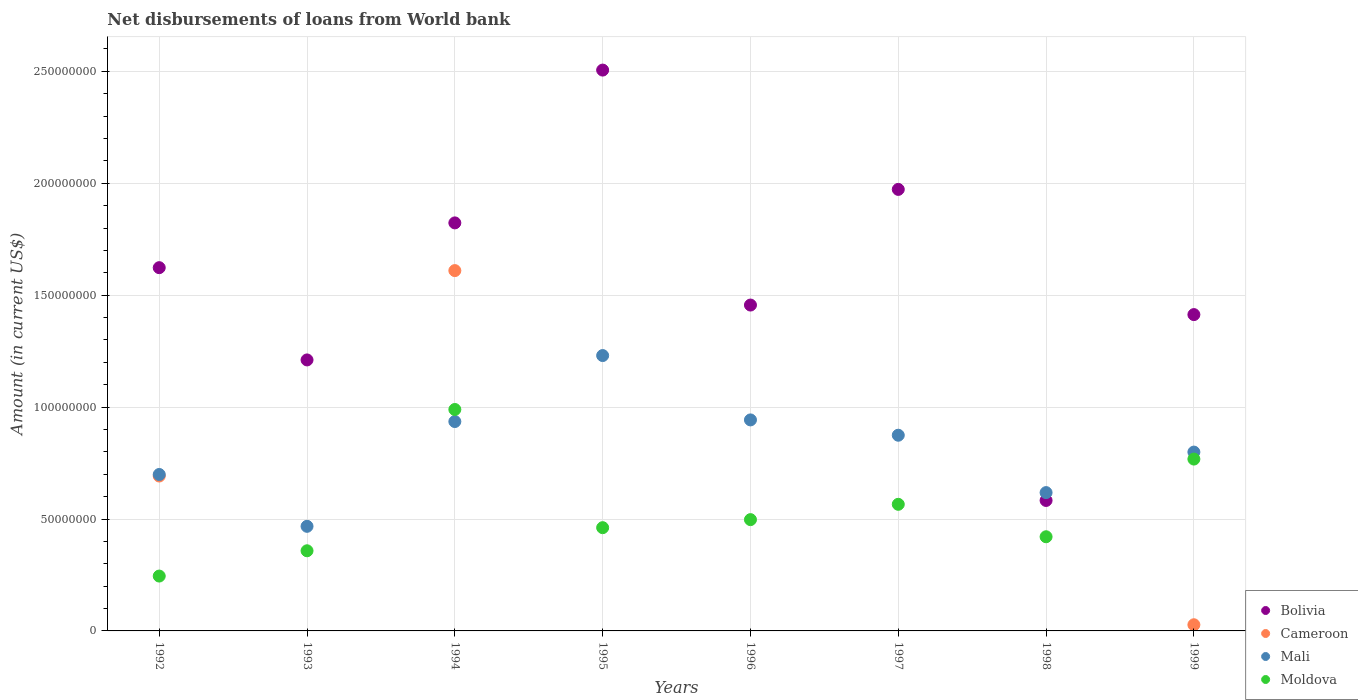Is the number of dotlines equal to the number of legend labels?
Your response must be concise. No. What is the amount of loan disbursed from World Bank in Moldova in 1997?
Offer a very short reply. 5.66e+07. Across all years, what is the maximum amount of loan disbursed from World Bank in Moldova?
Offer a terse response. 9.89e+07. Across all years, what is the minimum amount of loan disbursed from World Bank in Mali?
Ensure brevity in your answer.  4.67e+07. What is the total amount of loan disbursed from World Bank in Bolivia in the graph?
Offer a very short reply. 1.26e+09. What is the difference between the amount of loan disbursed from World Bank in Bolivia in 1992 and that in 1997?
Provide a succinct answer. -3.50e+07. What is the difference between the amount of loan disbursed from World Bank in Mali in 1992 and the amount of loan disbursed from World Bank in Bolivia in 1997?
Provide a succinct answer. -1.27e+08. What is the average amount of loan disbursed from World Bank in Moldova per year?
Give a very brief answer. 5.38e+07. In the year 1993, what is the difference between the amount of loan disbursed from World Bank in Bolivia and amount of loan disbursed from World Bank in Moldova?
Make the answer very short. 8.53e+07. In how many years, is the amount of loan disbursed from World Bank in Cameroon greater than 50000000 US$?
Offer a very short reply. 2. What is the ratio of the amount of loan disbursed from World Bank in Moldova in 1994 to that in 1998?
Give a very brief answer. 2.35. Is the amount of loan disbursed from World Bank in Bolivia in 1994 less than that in 1998?
Offer a very short reply. No. What is the difference between the highest and the second highest amount of loan disbursed from World Bank in Moldova?
Your response must be concise. 2.22e+07. What is the difference between the highest and the lowest amount of loan disbursed from World Bank in Bolivia?
Provide a succinct answer. 1.92e+08. In how many years, is the amount of loan disbursed from World Bank in Moldova greater than the average amount of loan disbursed from World Bank in Moldova taken over all years?
Provide a short and direct response. 3. Is the amount of loan disbursed from World Bank in Bolivia strictly less than the amount of loan disbursed from World Bank in Moldova over the years?
Your response must be concise. No. How many years are there in the graph?
Make the answer very short. 8. Are the values on the major ticks of Y-axis written in scientific E-notation?
Offer a very short reply. No. Where does the legend appear in the graph?
Offer a terse response. Bottom right. What is the title of the graph?
Your answer should be compact. Net disbursements of loans from World bank. Does "Slovenia" appear as one of the legend labels in the graph?
Give a very brief answer. No. What is the label or title of the Y-axis?
Offer a very short reply. Amount (in current US$). What is the Amount (in current US$) of Bolivia in 1992?
Your answer should be very brief. 1.62e+08. What is the Amount (in current US$) in Cameroon in 1992?
Give a very brief answer. 6.92e+07. What is the Amount (in current US$) in Mali in 1992?
Provide a short and direct response. 6.99e+07. What is the Amount (in current US$) of Moldova in 1992?
Offer a terse response. 2.45e+07. What is the Amount (in current US$) in Bolivia in 1993?
Provide a succinct answer. 1.21e+08. What is the Amount (in current US$) in Mali in 1993?
Your response must be concise. 4.67e+07. What is the Amount (in current US$) in Moldova in 1993?
Keep it short and to the point. 3.58e+07. What is the Amount (in current US$) in Bolivia in 1994?
Keep it short and to the point. 1.82e+08. What is the Amount (in current US$) in Cameroon in 1994?
Your response must be concise. 1.61e+08. What is the Amount (in current US$) in Mali in 1994?
Make the answer very short. 9.35e+07. What is the Amount (in current US$) of Moldova in 1994?
Ensure brevity in your answer.  9.89e+07. What is the Amount (in current US$) in Bolivia in 1995?
Your answer should be compact. 2.51e+08. What is the Amount (in current US$) of Mali in 1995?
Keep it short and to the point. 1.23e+08. What is the Amount (in current US$) of Moldova in 1995?
Make the answer very short. 4.61e+07. What is the Amount (in current US$) in Bolivia in 1996?
Ensure brevity in your answer.  1.46e+08. What is the Amount (in current US$) of Mali in 1996?
Keep it short and to the point. 9.43e+07. What is the Amount (in current US$) of Moldova in 1996?
Provide a short and direct response. 4.97e+07. What is the Amount (in current US$) of Bolivia in 1997?
Ensure brevity in your answer.  1.97e+08. What is the Amount (in current US$) of Cameroon in 1997?
Your answer should be compact. 0. What is the Amount (in current US$) of Mali in 1997?
Make the answer very short. 8.74e+07. What is the Amount (in current US$) in Moldova in 1997?
Ensure brevity in your answer.  5.66e+07. What is the Amount (in current US$) in Bolivia in 1998?
Your answer should be compact. 5.83e+07. What is the Amount (in current US$) in Mali in 1998?
Keep it short and to the point. 6.18e+07. What is the Amount (in current US$) of Moldova in 1998?
Offer a very short reply. 4.21e+07. What is the Amount (in current US$) in Bolivia in 1999?
Your response must be concise. 1.41e+08. What is the Amount (in current US$) in Cameroon in 1999?
Offer a terse response. 2.75e+06. What is the Amount (in current US$) of Mali in 1999?
Offer a very short reply. 7.99e+07. What is the Amount (in current US$) of Moldova in 1999?
Provide a succinct answer. 7.68e+07. Across all years, what is the maximum Amount (in current US$) of Bolivia?
Your response must be concise. 2.51e+08. Across all years, what is the maximum Amount (in current US$) of Cameroon?
Offer a very short reply. 1.61e+08. Across all years, what is the maximum Amount (in current US$) in Mali?
Your response must be concise. 1.23e+08. Across all years, what is the maximum Amount (in current US$) of Moldova?
Provide a short and direct response. 9.89e+07. Across all years, what is the minimum Amount (in current US$) of Bolivia?
Offer a terse response. 5.83e+07. Across all years, what is the minimum Amount (in current US$) in Cameroon?
Your answer should be very brief. 0. Across all years, what is the minimum Amount (in current US$) of Mali?
Your answer should be very brief. 4.67e+07. Across all years, what is the minimum Amount (in current US$) of Moldova?
Make the answer very short. 2.45e+07. What is the total Amount (in current US$) of Bolivia in the graph?
Your answer should be very brief. 1.26e+09. What is the total Amount (in current US$) of Cameroon in the graph?
Offer a very short reply. 2.33e+08. What is the total Amount (in current US$) of Mali in the graph?
Your answer should be very brief. 6.57e+08. What is the total Amount (in current US$) in Moldova in the graph?
Your answer should be very brief. 4.31e+08. What is the difference between the Amount (in current US$) in Bolivia in 1992 and that in 1993?
Your answer should be compact. 4.12e+07. What is the difference between the Amount (in current US$) in Mali in 1992 and that in 1993?
Ensure brevity in your answer.  2.32e+07. What is the difference between the Amount (in current US$) of Moldova in 1992 and that in 1993?
Make the answer very short. -1.13e+07. What is the difference between the Amount (in current US$) in Bolivia in 1992 and that in 1994?
Make the answer very short. -2.00e+07. What is the difference between the Amount (in current US$) of Cameroon in 1992 and that in 1994?
Your answer should be very brief. -9.18e+07. What is the difference between the Amount (in current US$) of Mali in 1992 and that in 1994?
Keep it short and to the point. -2.36e+07. What is the difference between the Amount (in current US$) of Moldova in 1992 and that in 1994?
Provide a succinct answer. -7.44e+07. What is the difference between the Amount (in current US$) in Bolivia in 1992 and that in 1995?
Your answer should be very brief. -8.83e+07. What is the difference between the Amount (in current US$) of Mali in 1992 and that in 1995?
Provide a succinct answer. -5.31e+07. What is the difference between the Amount (in current US$) in Moldova in 1992 and that in 1995?
Provide a short and direct response. -2.16e+07. What is the difference between the Amount (in current US$) of Bolivia in 1992 and that in 1996?
Your answer should be very brief. 1.67e+07. What is the difference between the Amount (in current US$) of Mali in 1992 and that in 1996?
Ensure brevity in your answer.  -2.44e+07. What is the difference between the Amount (in current US$) in Moldova in 1992 and that in 1996?
Offer a very short reply. -2.52e+07. What is the difference between the Amount (in current US$) of Bolivia in 1992 and that in 1997?
Provide a succinct answer. -3.50e+07. What is the difference between the Amount (in current US$) of Mali in 1992 and that in 1997?
Your response must be concise. -1.75e+07. What is the difference between the Amount (in current US$) of Moldova in 1992 and that in 1997?
Keep it short and to the point. -3.21e+07. What is the difference between the Amount (in current US$) of Bolivia in 1992 and that in 1998?
Your answer should be very brief. 1.04e+08. What is the difference between the Amount (in current US$) in Mali in 1992 and that in 1998?
Provide a succinct answer. 8.10e+06. What is the difference between the Amount (in current US$) of Moldova in 1992 and that in 1998?
Give a very brief answer. -1.76e+07. What is the difference between the Amount (in current US$) of Bolivia in 1992 and that in 1999?
Give a very brief answer. 2.10e+07. What is the difference between the Amount (in current US$) in Cameroon in 1992 and that in 1999?
Offer a terse response. 6.65e+07. What is the difference between the Amount (in current US$) of Mali in 1992 and that in 1999?
Keep it short and to the point. -1.00e+07. What is the difference between the Amount (in current US$) of Moldova in 1992 and that in 1999?
Give a very brief answer. -5.23e+07. What is the difference between the Amount (in current US$) in Bolivia in 1993 and that in 1994?
Provide a short and direct response. -6.12e+07. What is the difference between the Amount (in current US$) of Mali in 1993 and that in 1994?
Keep it short and to the point. -4.68e+07. What is the difference between the Amount (in current US$) of Moldova in 1993 and that in 1994?
Make the answer very short. -6.31e+07. What is the difference between the Amount (in current US$) in Bolivia in 1993 and that in 1995?
Your answer should be very brief. -1.29e+08. What is the difference between the Amount (in current US$) of Mali in 1993 and that in 1995?
Provide a short and direct response. -7.63e+07. What is the difference between the Amount (in current US$) of Moldova in 1993 and that in 1995?
Make the answer very short. -1.03e+07. What is the difference between the Amount (in current US$) in Bolivia in 1993 and that in 1996?
Your answer should be compact. -2.45e+07. What is the difference between the Amount (in current US$) in Mali in 1993 and that in 1996?
Your response must be concise. -4.75e+07. What is the difference between the Amount (in current US$) of Moldova in 1993 and that in 1996?
Provide a short and direct response. -1.39e+07. What is the difference between the Amount (in current US$) in Bolivia in 1993 and that in 1997?
Keep it short and to the point. -7.62e+07. What is the difference between the Amount (in current US$) in Mali in 1993 and that in 1997?
Offer a terse response. -4.07e+07. What is the difference between the Amount (in current US$) in Moldova in 1993 and that in 1997?
Offer a terse response. -2.08e+07. What is the difference between the Amount (in current US$) of Bolivia in 1993 and that in 1998?
Your response must be concise. 6.28e+07. What is the difference between the Amount (in current US$) in Mali in 1993 and that in 1998?
Your answer should be compact. -1.51e+07. What is the difference between the Amount (in current US$) in Moldova in 1993 and that in 1998?
Your answer should be compact. -6.27e+06. What is the difference between the Amount (in current US$) of Bolivia in 1993 and that in 1999?
Your answer should be compact. -2.03e+07. What is the difference between the Amount (in current US$) in Mali in 1993 and that in 1999?
Your answer should be compact. -3.32e+07. What is the difference between the Amount (in current US$) of Moldova in 1993 and that in 1999?
Ensure brevity in your answer.  -4.10e+07. What is the difference between the Amount (in current US$) of Bolivia in 1994 and that in 1995?
Ensure brevity in your answer.  -6.83e+07. What is the difference between the Amount (in current US$) of Mali in 1994 and that in 1995?
Provide a short and direct response. -2.95e+07. What is the difference between the Amount (in current US$) in Moldova in 1994 and that in 1995?
Provide a short and direct response. 5.28e+07. What is the difference between the Amount (in current US$) in Bolivia in 1994 and that in 1996?
Ensure brevity in your answer.  3.67e+07. What is the difference between the Amount (in current US$) in Mali in 1994 and that in 1996?
Offer a very short reply. -7.32e+05. What is the difference between the Amount (in current US$) in Moldova in 1994 and that in 1996?
Your answer should be compact. 4.92e+07. What is the difference between the Amount (in current US$) in Bolivia in 1994 and that in 1997?
Offer a very short reply. -1.50e+07. What is the difference between the Amount (in current US$) in Mali in 1994 and that in 1997?
Offer a very short reply. 6.11e+06. What is the difference between the Amount (in current US$) of Moldova in 1994 and that in 1997?
Give a very brief answer. 4.24e+07. What is the difference between the Amount (in current US$) in Bolivia in 1994 and that in 1998?
Ensure brevity in your answer.  1.24e+08. What is the difference between the Amount (in current US$) of Mali in 1994 and that in 1998?
Provide a succinct answer. 3.17e+07. What is the difference between the Amount (in current US$) of Moldova in 1994 and that in 1998?
Offer a terse response. 5.69e+07. What is the difference between the Amount (in current US$) in Bolivia in 1994 and that in 1999?
Keep it short and to the point. 4.10e+07. What is the difference between the Amount (in current US$) in Cameroon in 1994 and that in 1999?
Keep it short and to the point. 1.58e+08. What is the difference between the Amount (in current US$) of Mali in 1994 and that in 1999?
Keep it short and to the point. 1.36e+07. What is the difference between the Amount (in current US$) in Moldova in 1994 and that in 1999?
Provide a succinct answer. 2.22e+07. What is the difference between the Amount (in current US$) of Bolivia in 1995 and that in 1996?
Your answer should be very brief. 1.05e+08. What is the difference between the Amount (in current US$) of Mali in 1995 and that in 1996?
Offer a very short reply. 2.87e+07. What is the difference between the Amount (in current US$) of Moldova in 1995 and that in 1996?
Your answer should be very brief. -3.59e+06. What is the difference between the Amount (in current US$) of Bolivia in 1995 and that in 1997?
Offer a terse response. 5.33e+07. What is the difference between the Amount (in current US$) in Mali in 1995 and that in 1997?
Give a very brief answer. 3.56e+07. What is the difference between the Amount (in current US$) in Moldova in 1995 and that in 1997?
Provide a succinct answer. -1.04e+07. What is the difference between the Amount (in current US$) of Bolivia in 1995 and that in 1998?
Ensure brevity in your answer.  1.92e+08. What is the difference between the Amount (in current US$) in Mali in 1995 and that in 1998?
Keep it short and to the point. 6.12e+07. What is the difference between the Amount (in current US$) in Moldova in 1995 and that in 1998?
Offer a very short reply. 4.06e+06. What is the difference between the Amount (in current US$) in Bolivia in 1995 and that in 1999?
Provide a short and direct response. 1.09e+08. What is the difference between the Amount (in current US$) of Mali in 1995 and that in 1999?
Offer a terse response. 4.31e+07. What is the difference between the Amount (in current US$) of Moldova in 1995 and that in 1999?
Offer a very short reply. -3.07e+07. What is the difference between the Amount (in current US$) of Bolivia in 1996 and that in 1997?
Offer a very short reply. -5.17e+07. What is the difference between the Amount (in current US$) of Mali in 1996 and that in 1997?
Make the answer very short. 6.85e+06. What is the difference between the Amount (in current US$) in Moldova in 1996 and that in 1997?
Your answer should be compact. -6.85e+06. What is the difference between the Amount (in current US$) in Bolivia in 1996 and that in 1998?
Give a very brief answer. 8.73e+07. What is the difference between the Amount (in current US$) in Mali in 1996 and that in 1998?
Keep it short and to the point. 3.25e+07. What is the difference between the Amount (in current US$) in Moldova in 1996 and that in 1998?
Offer a very short reply. 7.65e+06. What is the difference between the Amount (in current US$) in Bolivia in 1996 and that in 1999?
Make the answer very short. 4.26e+06. What is the difference between the Amount (in current US$) of Mali in 1996 and that in 1999?
Provide a succinct answer. 1.44e+07. What is the difference between the Amount (in current US$) of Moldova in 1996 and that in 1999?
Make the answer very short. -2.71e+07. What is the difference between the Amount (in current US$) of Bolivia in 1997 and that in 1998?
Offer a terse response. 1.39e+08. What is the difference between the Amount (in current US$) of Mali in 1997 and that in 1998?
Provide a succinct answer. 2.56e+07. What is the difference between the Amount (in current US$) in Moldova in 1997 and that in 1998?
Provide a short and direct response. 1.45e+07. What is the difference between the Amount (in current US$) in Bolivia in 1997 and that in 1999?
Your answer should be very brief. 5.59e+07. What is the difference between the Amount (in current US$) in Mali in 1997 and that in 1999?
Your response must be concise. 7.53e+06. What is the difference between the Amount (in current US$) in Moldova in 1997 and that in 1999?
Ensure brevity in your answer.  -2.02e+07. What is the difference between the Amount (in current US$) in Bolivia in 1998 and that in 1999?
Make the answer very short. -8.30e+07. What is the difference between the Amount (in current US$) of Mali in 1998 and that in 1999?
Your answer should be very brief. -1.81e+07. What is the difference between the Amount (in current US$) of Moldova in 1998 and that in 1999?
Offer a very short reply. -3.47e+07. What is the difference between the Amount (in current US$) in Bolivia in 1992 and the Amount (in current US$) in Mali in 1993?
Your response must be concise. 1.16e+08. What is the difference between the Amount (in current US$) of Bolivia in 1992 and the Amount (in current US$) of Moldova in 1993?
Keep it short and to the point. 1.26e+08. What is the difference between the Amount (in current US$) in Cameroon in 1992 and the Amount (in current US$) in Mali in 1993?
Ensure brevity in your answer.  2.25e+07. What is the difference between the Amount (in current US$) of Cameroon in 1992 and the Amount (in current US$) of Moldova in 1993?
Ensure brevity in your answer.  3.34e+07. What is the difference between the Amount (in current US$) of Mali in 1992 and the Amount (in current US$) of Moldova in 1993?
Your response must be concise. 3.41e+07. What is the difference between the Amount (in current US$) of Bolivia in 1992 and the Amount (in current US$) of Cameroon in 1994?
Provide a succinct answer. 1.31e+06. What is the difference between the Amount (in current US$) in Bolivia in 1992 and the Amount (in current US$) in Mali in 1994?
Give a very brief answer. 6.87e+07. What is the difference between the Amount (in current US$) of Bolivia in 1992 and the Amount (in current US$) of Moldova in 1994?
Provide a succinct answer. 6.34e+07. What is the difference between the Amount (in current US$) of Cameroon in 1992 and the Amount (in current US$) of Mali in 1994?
Make the answer very short. -2.43e+07. What is the difference between the Amount (in current US$) of Cameroon in 1992 and the Amount (in current US$) of Moldova in 1994?
Ensure brevity in your answer.  -2.97e+07. What is the difference between the Amount (in current US$) in Mali in 1992 and the Amount (in current US$) in Moldova in 1994?
Provide a succinct answer. -2.90e+07. What is the difference between the Amount (in current US$) in Bolivia in 1992 and the Amount (in current US$) in Mali in 1995?
Provide a short and direct response. 3.93e+07. What is the difference between the Amount (in current US$) of Bolivia in 1992 and the Amount (in current US$) of Moldova in 1995?
Make the answer very short. 1.16e+08. What is the difference between the Amount (in current US$) of Cameroon in 1992 and the Amount (in current US$) of Mali in 1995?
Make the answer very short. -5.38e+07. What is the difference between the Amount (in current US$) of Cameroon in 1992 and the Amount (in current US$) of Moldova in 1995?
Give a very brief answer. 2.31e+07. What is the difference between the Amount (in current US$) in Mali in 1992 and the Amount (in current US$) in Moldova in 1995?
Your answer should be very brief. 2.38e+07. What is the difference between the Amount (in current US$) of Bolivia in 1992 and the Amount (in current US$) of Mali in 1996?
Your response must be concise. 6.80e+07. What is the difference between the Amount (in current US$) of Bolivia in 1992 and the Amount (in current US$) of Moldova in 1996?
Your answer should be compact. 1.13e+08. What is the difference between the Amount (in current US$) in Cameroon in 1992 and the Amount (in current US$) in Mali in 1996?
Give a very brief answer. -2.51e+07. What is the difference between the Amount (in current US$) of Cameroon in 1992 and the Amount (in current US$) of Moldova in 1996?
Your answer should be compact. 1.95e+07. What is the difference between the Amount (in current US$) in Mali in 1992 and the Amount (in current US$) in Moldova in 1996?
Keep it short and to the point. 2.02e+07. What is the difference between the Amount (in current US$) in Bolivia in 1992 and the Amount (in current US$) in Mali in 1997?
Your response must be concise. 7.49e+07. What is the difference between the Amount (in current US$) of Bolivia in 1992 and the Amount (in current US$) of Moldova in 1997?
Provide a succinct answer. 1.06e+08. What is the difference between the Amount (in current US$) of Cameroon in 1992 and the Amount (in current US$) of Mali in 1997?
Your answer should be compact. -1.82e+07. What is the difference between the Amount (in current US$) of Cameroon in 1992 and the Amount (in current US$) of Moldova in 1997?
Provide a short and direct response. 1.26e+07. What is the difference between the Amount (in current US$) in Mali in 1992 and the Amount (in current US$) in Moldova in 1997?
Your answer should be very brief. 1.33e+07. What is the difference between the Amount (in current US$) in Bolivia in 1992 and the Amount (in current US$) in Mali in 1998?
Provide a short and direct response. 1.00e+08. What is the difference between the Amount (in current US$) of Bolivia in 1992 and the Amount (in current US$) of Moldova in 1998?
Offer a terse response. 1.20e+08. What is the difference between the Amount (in current US$) in Cameroon in 1992 and the Amount (in current US$) in Mali in 1998?
Your response must be concise. 7.41e+06. What is the difference between the Amount (in current US$) of Cameroon in 1992 and the Amount (in current US$) of Moldova in 1998?
Your answer should be very brief. 2.71e+07. What is the difference between the Amount (in current US$) of Mali in 1992 and the Amount (in current US$) of Moldova in 1998?
Give a very brief answer. 2.78e+07. What is the difference between the Amount (in current US$) in Bolivia in 1992 and the Amount (in current US$) in Cameroon in 1999?
Provide a succinct answer. 1.60e+08. What is the difference between the Amount (in current US$) in Bolivia in 1992 and the Amount (in current US$) in Mali in 1999?
Offer a very short reply. 8.24e+07. What is the difference between the Amount (in current US$) in Bolivia in 1992 and the Amount (in current US$) in Moldova in 1999?
Provide a short and direct response. 8.55e+07. What is the difference between the Amount (in current US$) of Cameroon in 1992 and the Amount (in current US$) of Mali in 1999?
Ensure brevity in your answer.  -1.07e+07. What is the difference between the Amount (in current US$) of Cameroon in 1992 and the Amount (in current US$) of Moldova in 1999?
Your answer should be very brief. -7.58e+06. What is the difference between the Amount (in current US$) in Mali in 1992 and the Amount (in current US$) in Moldova in 1999?
Keep it short and to the point. -6.88e+06. What is the difference between the Amount (in current US$) in Bolivia in 1993 and the Amount (in current US$) in Cameroon in 1994?
Keep it short and to the point. -3.99e+07. What is the difference between the Amount (in current US$) in Bolivia in 1993 and the Amount (in current US$) in Mali in 1994?
Keep it short and to the point. 2.75e+07. What is the difference between the Amount (in current US$) of Bolivia in 1993 and the Amount (in current US$) of Moldova in 1994?
Ensure brevity in your answer.  2.21e+07. What is the difference between the Amount (in current US$) of Mali in 1993 and the Amount (in current US$) of Moldova in 1994?
Give a very brief answer. -5.22e+07. What is the difference between the Amount (in current US$) in Bolivia in 1993 and the Amount (in current US$) in Mali in 1995?
Your answer should be very brief. -1.95e+06. What is the difference between the Amount (in current US$) of Bolivia in 1993 and the Amount (in current US$) of Moldova in 1995?
Provide a short and direct response. 7.49e+07. What is the difference between the Amount (in current US$) in Mali in 1993 and the Amount (in current US$) in Moldova in 1995?
Provide a succinct answer. 6.07e+05. What is the difference between the Amount (in current US$) of Bolivia in 1993 and the Amount (in current US$) of Mali in 1996?
Your response must be concise. 2.68e+07. What is the difference between the Amount (in current US$) of Bolivia in 1993 and the Amount (in current US$) of Moldova in 1996?
Offer a terse response. 7.14e+07. What is the difference between the Amount (in current US$) in Mali in 1993 and the Amount (in current US$) in Moldova in 1996?
Your answer should be compact. -2.98e+06. What is the difference between the Amount (in current US$) in Bolivia in 1993 and the Amount (in current US$) in Mali in 1997?
Offer a terse response. 3.36e+07. What is the difference between the Amount (in current US$) of Bolivia in 1993 and the Amount (in current US$) of Moldova in 1997?
Offer a terse response. 6.45e+07. What is the difference between the Amount (in current US$) of Mali in 1993 and the Amount (in current US$) of Moldova in 1997?
Ensure brevity in your answer.  -9.83e+06. What is the difference between the Amount (in current US$) in Bolivia in 1993 and the Amount (in current US$) in Mali in 1998?
Provide a succinct answer. 5.93e+07. What is the difference between the Amount (in current US$) in Bolivia in 1993 and the Amount (in current US$) in Moldova in 1998?
Provide a short and direct response. 7.90e+07. What is the difference between the Amount (in current US$) of Mali in 1993 and the Amount (in current US$) of Moldova in 1998?
Offer a terse response. 4.66e+06. What is the difference between the Amount (in current US$) in Bolivia in 1993 and the Amount (in current US$) in Cameroon in 1999?
Keep it short and to the point. 1.18e+08. What is the difference between the Amount (in current US$) of Bolivia in 1993 and the Amount (in current US$) of Mali in 1999?
Your answer should be compact. 4.12e+07. What is the difference between the Amount (in current US$) of Bolivia in 1993 and the Amount (in current US$) of Moldova in 1999?
Your answer should be compact. 4.43e+07. What is the difference between the Amount (in current US$) in Mali in 1993 and the Amount (in current US$) in Moldova in 1999?
Your answer should be very brief. -3.00e+07. What is the difference between the Amount (in current US$) of Bolivia in 1994 and the Amount (in current US$) of Mali in 1995?
Provide a succinct answer. 5.93e+07. What is the difference between the Amount (in current US$) of Bolivia in 1994 and the Amount (in current US$) of Moldova in 1995?
Your response must be concise. 1.36e+08. What is the difference between the Amount (in current US$) of Cameroon in 1994 and the Amount (in current US$) of Mali in 1995?
Your response must be concise. 3.80e+07. What is the difference between the Amount (in current US$) in Cameroon in 1994 and the Amount (in current US$) in Moldova in 1995?
Ensure brevity in your answer.  1.15e+08. What is the difference between the Amount (in current US$) in Mali in 1994 and the Amount (in current US$) in Moldova in 1995?
Give a very brief answer. 4.74e+07. What is the difference between the Amount (in current US$) in Bolivia in 1994 and the Amount (in current US$) in Mali in 1996?
Give a very brief answer. 8.80e+07. What is the difference between the Amount (in current US$) of Bolivia in 1994 and the Amount (in current US$) of Moldova in 1996?
Offer a terse response. 1.33e+08. What is the difference between the Amount (in current US$) of Cameroon in 1994 and the Amount (in current US$) of Mali in 1996?
Provide a short and direct response. 6.67e+07. What is the difference between the Amount (in current US$) of Cameroon in 1994 and the Amount (in current US$) of Moldova in 1996?
Offer a terse response. 1.11e+08. What is the difference between the Amount (in current US$) of Mali in 1994 and the Amount (in current US$) of Moldova in 1996?
Your answer should be very brief. 4.38e+07. What is the difference between the Amount (in current US$) in Bolivia in 1994 and the Amount (in current US$) in Mali in 1997?
Provide a succinct answer. 9.49e+07. What is the difference between the Amount (in current US$) of Bolivia in 1994 and the Amount (in current US$) of Moldova in 1997?
Ensure brevity in your answer.  1.26e+08. What is the difference between the Amount (in current US$) in Cameroon in 1994 and the Amount (in current US$) in Mali in 1997?
Provide a succinct answer. 7.36e+07. What is the difference between the Amount (in current US$) of Cameroon in 1994 and the Amount (in current US$) of Moldova in 1997?
Your response must be concise. 1.04e+08. What is the difference between the Amount (in current US$) in Mali in 1994 and the Amount (in current US$) in Moldova in 1997?
Your answer should be compact. 3.70e+07. What is the difference between the Amount (in current US$) in Bolivia in 1994 and the Amount (in current US$) in Mali in 1998?
Give a very brief answer. 1.21e+08. What is the difference between the Amount (in current US$) of Bolivia in 1994 and the Amount (in current US$) of Moldova in 1998?
Make the answer very short. 1.40e+08. What is the difference between the Amount (in current US$) in Cameroon in 1994 and the Amount (in current US$) in Mali in 1998?
Provide a short and direct response. 9.92e+07. What is the difference between the Amount (in current US$) of Cameroon in 1994 and the Amount (in current US$) of Moldova in 1998?
Give a very brief answer. 1.19e+08. What is the difference between the Amount (in current US$) of Mali in 1994 and the Amount (in current US$) of Moldova in 1998?
Your answer should be compact. 5.15e+07. What is the difference between the Amount (in current US$) in Bolivia in 1994 and the Amount (in current US$) in Cameroon in 1999?
Provide a short and direct response. 1.80e+08. What is the difference between the Amount (in current US$) in Bolivia in 1994 and the Amount (in current US$) in Mali in 1999?
Your answer should be very brief. 1.02e+08. What is the difference between the Amount (in current US$) of Bolivia in 1994 and the Amount (in current US$) of Moldova in 1999?
Offer a very short reply. 1.06e+08. What is the difference between the Amount (in current US$) of Cameroon in 1994 and the Amount (in current US$) of Mali in 1999?
Ensure brevity in your answer.  8.11e+07. What is the difference between the Amount (in current US$) of Cameroon in 1994 and the Amount (in current US$) of Moldova in 1999?
Ensure brevity in your answer.  8.42e+07. What is the difference between the Amount (in current US$) of Mali in 1994 and the Amount (in current US$) of Moldova in 1999?
Your response must be concise. 1.68e+07. What is the difference between the Amount (in current US$) of Bolivia in 1995 and the Amount (in current US$) of Mali in 1996?
Ensure brevity in your answer.  1.56e+08. What is the difference between the Amount (in current US$) in Bolivia in 1995 and the Amount (in current US$) in Moldova in 1996?
Give a very brief answer. 2.01e+08. What is the difference between the Amount (in current US$) in Mali in 1995 and the Amount (in current US$) in Moldova in 1996?
Your answer should be very brief. 7.33e+07. What is the difference between the Amount (in current US$) of Bolivia in 1995 and the Amount (in current US$) of Mali in 1997?
Offer a very short reply. 1.63e+08. What is the difference between the Amount (in current US$) of Bolivia in 1995 and the Amount (in current US$) of Moldova in 1997?
Keep it short and to the point. 1.94e+08. What is the difference between the Amount (in current US$) in Mali in 1995 and the Amount (in current US$) in Moldova in 1997?
Offer a terse response. 6.65e+07. What is the difference between the Amount (in current US$) of Bolivia in 1995 and the Amount (in current US$) of Mali in 1998?
Keep it short and to the point. 1.89e+08. What is the difference between the Amount (in current US$) in Bolivia in 1995 and the Amount (in current US$) in Moldova in 1998?
Your answer should be compact. 2.08e+08. What is the difference between the Amount (in current US$) of Mali in 1995 and the Amount (in current US$) of Moldova in 1998?
Offer a very short reply. 8.10e+07. What is the difference between the Amount (in current US$) in Bolivia in 1995 and the Amount (in current US$) in Cameroon in 1999?
Give a very brief answer. 2.48e+08. What is the difference between the Amount (in current US$) in Bolivia in 1995 and the Amount (in current US$) in Mali in 1999?
Provide a short and direct response. 1.71e+08. What is the difference between the Amount (in current US$) of Bolivia in 1995 and the Amount (in current US$) of Moldova in 1999?
Give a very brief answer. 1.74e+08. What is the difference between the Amount (in current US$) in Mali in 1995 and the Amount (in current US$) in Moldova in 1999?
Keep it short and to the point. 4.62e+07. What is the difference between the Amount (in current US$) of Bolivia in 1996 and the Amount (in current US$) of Mali in 1997?
Your answer should be very brief. 5.82e+07. What is the difference between the Amount (in current US$) of Bolivia in 1996 and the Amount (in current US$) of Moldova in 1997?
Offer a terse response. 8.90e+07. What is the difference between the Amount (in current US$) in Mali in 1996 and the Amount (in current US$) in Moldova in 1997?
Keep it short and to the point. 3.77e+07. What is the difference between the Amount (in current US$) in Bolivia in 1996 and the Amount (in current US$) in Mali in 1998?
Give a very brief answer. 8.38e+07. What is the difference between the Amount (in current US$) of Bolivia in 1996 and the Amount (in current US$) of Moldova in 1998?
Your answer should be compact. 1.04e+08. What is the difference between the Amount (in current US$) in Mali in 1996 and the Amount (in current US$) in Moldova in 1998?
Your answer should be very brief. 5.22e+07. What is the difference between the Amount (in current US$) of Bolivia in 1996 and the Amount (in current US$) of Cameroon in 1999?
Your response must be concise. 1.43e+08. What is the difference between the Amount (in current US$) in Bolivia in 1996 and the Amount (in current US$) in Mali in 1999?
Your response must be concise. 6.57e+07. What is the difference between the Amount (in current US$) in Bolivia in 1996 and the Amount (in current US$) in Moldova in 1999?
Your answer should be very brief. 6.88e+07. What is the difference between the Amount (in current US$) in Mali in 1996 and the Amount (in current US$) in Moldova in 1999?
Your answer should be compact. 1.75e+07. What is the difference between the Amount (in current US$) in Bolivia in 1997 and the Amount (in current US$) in Mali in 1998?
Make the answer very short. 1.35e+08. What is the difference between the Amount (in current US$) of Bolivia in 1997 and the Amount (in current US$) of Moldova in 1998?
Your response must be concise. 1.55e+08. What is the difference between the Amount (in current US$) in Mali in 1997 and the Amount (in current US$) in Moldova in 1998?
Offer a terse response. 4.54e+07. What is the difference between the Amount (in current US$) in Bolivia in 1997 and the Amount (in current US$) in Cameroon in 1999?
Keep it short and to the point. 1.95e+08. What is the difference between the Amount (in current US$) in Bolivia in 1997 and the Amount (in current US$) in Mali in 1999?
Your answer should be very brief. 1.17e+08. What is the difference between the Amount (in current US$) of Bolivia in 1997 and the Amount (in current US$) of Moldova in 1999?
Keep it short and to the point. 1.20e+08. What is the difference between the Amount (in current US$) of Mali in 1997 and the Amount (in current US$) of Moldova in 1999?
Give a very brief answer. 1.07e+07. What is the difference between the Amount (in current US$) of Bolivia in 1998 and the Amount (in current US$) of Cameroon in 1999?
Keep it short and to the point. 5.55e+07. What is the difference between the Amount (in current US$) in Bolivia in 1998 and the Amount (in current US$) in Mali in 1999?
Offer a very short reply. -2.16e+07. What is the difference between the Amount (in current US$) of Bolivia in 1998 and the Amount (in current US$) of Moldova in 1999?
Offer a terse response. -1.85e+07. What is the difference between the Amount (in current US$) in Mali in 1998 and the Amount (in current US$) in Moldova in 1999?
Your answer should be compact. -1.50e+07. What is the average Amount (in current US$) of Bolivia per year?
Your response must be concise. 1.57e+08. What is the average Amount (in current US$) of Cameroon per year?
Your response must be concise. 2.91e+07. What is the average Amount (in current US$) of Mali per year?
Give a very brief answer. 8.21e+07. What is the average Amount (in current US$) in Moldova per year?
Ensure brevity in your answer.  5.38e+07. In the year 1992, what is the difference between the Amount (in current US$) in Bolivia and Amount (in current US$) in Cameroon?
Your response must be concise. 9.31e+07. In the year 1992, what is the difference between the Amount (in current US$) of Bolivia and Amount (in current US$) of Mali?
Give a very brief answer. 9.24e+07. In the year 1992, what is the difference between the Amount (in current US$) in Bolivia and Amount (in current US$) in Moldova?
Offer a very short reply. 1.38e+08. In the year 1992, what is the difference between the Amount (in current US$) of Cameroon and Amount (in current US$) of Mali?
Your response must be concise. -6.91e+05. In the year 1992, what is the difference between the Amount (in current US$) of Cameroon and Amount (in current US$) of Moldova?
Provide a succinct answer. 4.47e+07. In the year 1992, what is the difference between the Amount (in current US$) in Mali and Amount (in current US$) in Moldova?
Ensure brevity in your answer.  4.54e+07. In the year 1993, what is the difference between the Amount (in current US$) in Bolivia and Amount (in current US$) in Mali?
Keep it short and to the point. 7.43e+07. In the year 1993, what is the difference between the Amount (in current US$) of Bolivia and Amount (in current US$) of Moldova?
Offer a terse response. 8.53e+07. In the year 1993, what is the difference between the Amount (in current US$) in Mali and Amount (in current US$) in Moldova?
Offer a terse response. 1.09e+07. In the year 1994, what is the difference between the Amount (in current US$) of Bolivia and Amount (in current US$) of Cameroon?
Provide a short and direct response. 2.13e+07. In the year 1994, what is the difference between the Amount (in current US$) in Bolivia and Amount (in current US$) in Mali?
Offer a very short reply. 8.88e+07. In the year 1994, what is the difference between the Amount (in current US$) of Bolivia and Amount (in current US$) of Moldova?
Provide a short and direct response. 8.34e+07. In the year 1994, what is the difference between the Amount (in current US$) of Cameroon and Amount (in current US$) of Mali?
Make the answer very short. 6.74e+07. In the year 1994, what is the difference between the Amount (in current US$) of Cameroon and Amount (in current US$) of Moldova?
Ensure brevity in your answer.  6.21e+07. In the year 1994, what is the difference between the Amount (in current US$) in Mali and Amount (in current US$) in Moldova?
Ensure brevity in your answer.  -5.39e+06. In the year 1995, what is the difference between the Amount (in current US$) in Bolivia and Amount (in current US$) in Mali?
Provide a succinct answer. 1.28e+08. In the year 1995, what is the difference between the Amount (in current US$) of Bolivia and Amount (in current US$) of Moldova?
Your response must be concise. 2.04e+08. In the year 1995, what is the difference between the Amount (in current US$) of Mali and Amount (in current US$) of Moldova?
Your answer should be very brief. 7.69e+07. In the year 1996, what is the difference between the Amount (in current US$) in Bolivia and Amount (in current US$) in Mali?
Your answer should be very brief. 5.13e+07. In the year 1996, what is the difference between the Amount (in current US$) of Bolivia and Amount (in current US$) of Moldova?
Offer a very short reply. 9.59e+07. In the year 1996, what is the difference between the Amount (in current US$) in Mali and Amount (in current US$) in Moldova?
Make the answer very short. 4.46e+07. In the year 1997, what is the difference between the Amount (in current US$) of Bolivia and Amount (in current US$) of Mali?
Your answer should be very brief. 1.10e+08. In the year 1997, what is the difference between the Amount (in current US$) in Bolivia and Amount (in current US$) in Moldova?
Your answer should be very brief. 1.41e+08. In the year 1997, what is the difference between the Amount (in current US$) in Mali and Amount (in current US$) in Moldova?
Offer a very short reply. 3.09e+07. In the year 1998, what is the difference between the Amount (in current US$) in Bolivia and Amount (in current US$) in Mali?
Offer a very short reply. -3.51e+06. In the year 1998, what is the difference between the Amount (in current US$) of Bolivia and Amount (in current US$) of Moldova?
Your response must be concise. 1.62e+07. In the year 1998, what is the difference between the Amount (in current US$) of Mali and Amount (in current US$) of Moldova?
Give a very brief answer. 1.97e+07. In the year 1999, what is the difference between the Amount (in current US$) of Bolivia and Amount (in current US$) of Cameroon?
Your response must be concise. 1.39e+08. In the year 1999, what is the difference between the Amount (in current US$) in Bolivia and Amount (in current US$) in Mali?
Make the answer very short. 6.14e+07. In the year 1999, what is the difference between the Amount (in current US$) of Bolivia and Amount (in current US$) of Moldova?
Keep it short and to the point. 6.45e+07. In the year 1999, what is the difference between the Amount (in current US$) in Cameroon and Amount (in current US$) in Mali?
Offer a terse response. -7.71e+07. In the year 1999, what is the difference between the Amount (in current US$) in Cameroon and Amount (in current US$) in Moldova?
Your answer should be very brief. -7.40e+07. In the year 1999, what is the difference between the Amount (in current US$) in Mali and Amount (in current US$) in Moldova?
Your answer should be very brief. 3.12e+06. What is the ratio of the Amount (in current US$) of Bolivia in 1992 to that in 1993?
Keep it short and to the point. 1.34. What is the ratio of the Amount (in current US$) of Mali in 1992 to that in 1993?
Give a very brief answer. 1.5. What is the ratio of the Amount (in current US$) of Moldova in 1992 to that in 1993?
Offer a terse response. 0.68. What is the ratio of the Amount (in current US$) of Bolivia in 1992 to that in 1994?
Ensure brevity in your answer.  0.89. What is the ratio of the Amount (in current US$) of Cameroon in 1992 to that in 1994?
Provide a short and direct response. 0.43. What is the ratio of the Amount (in current US$) of Mali in 1992 to that in 1994?
Make the answer very short. 0.75. What is the ratio of the Amount (in current US$) of Moldova in 1992 to that in 1994?
Keep it short and to the point. 0.25. What is the ratio of the Amount (in current US$) of Bolivia in 1992 to that in 1995?
Your response must be concise. 0.65. What is the ratio of the Amount (in current US$) of Mali in 1992 to that in 1995?
Ensure brevity in your answer.  0.57. What is the ratio of the Amount (in current US$) in Moldova in 1992 to that in 1995?
Provide a short and direct response. 0.53. What is the ratio of the Amount (in current US$) of Bolivia in 1992 to that in 1996?
Offer a very short reply. 1.11. What is the ratio of the Amount (in current US$) in Mali in 1992 to that in 1996?
Offer a very short reply. 0.74. What is the ratio of the Amount (in current US$) of Moldova in 1992 to that in 1996?
Your response must be concise. 0.49. What is the ratio of the Amount (in current US$) in Bolivia in 1992 to that in 1997?
Provide a short and direct response. 0.82. What is the ratio of the Amount (in current US$) of Mali in 1992 to that in 1997?
Keep it short and to the point. 0.8. What is the ratio of the Amount (in current US$) in Moldova in 1992 to that in 1997?
Your answer should be very brief. 0.43. What is the ratio of the Amount (in current US$) of Bolivia in 1992 to that in 1998?
Offer a very short reply. 2.78. What is the ratio of the Amount (in current US$) in Mali in 1992 to that in 1998?
Offer a very short reply. 1.13. What is the ratio of the Amount (in current US$) of Moldova in 1992 to that in 1998?
Give a very brief answer. 0.58. What is the ratio of the Amount (in current US$) of Bolivia in 1992 to that in 1999?
Offer a very short reply. 1.15. What is the ratio of the Amount (in current US$) in Cameroon in 1992 to that in 1999?
Your answer should be compact. 25.14. What is the ratio of the Amount (in current US$) in Mali in 1992 to that in 1999?
Keep it short and to the point. 0.87. What is the ratio of the Amount (in current US$) of Moldova in 1992 to that in 1999?
Provide a succinct answer. 0.32. What is the ratio of the Amount (in current US$) of Bolivia in 1993 to that in 1994?
Your answer should be compact. 0.66. What is the ratio of the Amount (in current US$) of Mali in 1993 to that in 1994?
Your response must be concise. 0.5. What is the ratio of the Amount (in current US$) in Moldova in 1993 to that in 1994?
Your answer should be very brief. 0.36. What is the ratio of the Amount (in current US$) of Bolivia in 1993 to that in 1995?
Your answer should be very brief. 0.48. What is the ratio of the Amount (in current US$) of Mali in 1993 to that in 1995?
Provide a short and direct response. 0.38. What is the ratio of the Amount (in current US$) of Moldova in 1993 to that in 1995?
Give a very brief answer. 0.78. What is the ratio of the Amount (in current US$) of Bolivia in 1993 to that in 1996?
Your answer should be compact. 0.83. What is the ratio of the Amount (in current US$) in Mali in 1993 to that in 1996?
Your answer should be very brief. 0.5. What is the ratio of the Amount (in current US$) in Moldova in 1993 to that in 1996?
Your answer should be compact. 0.72. What is the ratio of the Amount (in current US$) in Bolivia in 1993 to that in 1997?
Make the answer very short. 0.61. What is the ratio of the Amount (in current US$) in Mali in 1993 to that in 1997?
Make the answer very short. 0.53. What is the ratio of the Amount (in current US$) of Moldova in 1993 to that in 1997?
Your answer should be compact. 0.63. What is the ratio of the Amount (in current US$) in Bolivia in 1993 to that in 1998?
Your answer should be very brief. 2.08. What is the ratio of the Amount (in current US$) of Mali in 1993 to that in 1998?
Your answer should be very brief. 0.76. What is the ratio of the Amount (in current US$) of Moldova in 1993 to that in 1998?
Make the answer very short. 0.85. What is the ratio of the Amount (in current US$) in Bolivia in 1993 to that in 1999?
Your answer should be compact. 0.86. What is the ratio of the Amount (in current US$) of Mali in 1993 to that in 1999?
Provide a succinct answer. 0.58. What is the ratio of the Amount (in current US$) in Moldova in 1993 to that in 1999?
Keep it short and to the point. 0.47. What is the ratio of the Amount (in current US$) in Bolivia in 1994 to that in 1995?
Provide a short and direct response. 0.73. What is the ratio of the Amount (in current US$) in Mali in 1994 to that in 1995?
Provide a short and direct response. 0.76. What is the ratio of the Amount (in current US$) in Moldova in 1994 to that in 1995?
Offer a terse response. 2.14. What is the ratio of the Amount (in current US$) in Bolivia in 1994 to that in 1996?
Give a very brief answer. 1.25. What is the ratio of the Amount (in current US$) in Moldova in 1994 to that in 1996?
Ensure brevity in your answer.  1.99. What is the ratio of the Amount (in current US$) of Bolivia in 1994 to that in 1997?
Offer a terse response. 0.92. What is the ratio of the Amount (in current US$) of Mali in 1994 to that in 1997?
Your answer should be compact. 1.07. What is the ratio of the Amount (in current US$) in Moldova in 1994 to that in 1997?
Your answer should be very brief. 1.75. What is the ratio of the Amount (in current US$) of Bolivia in 1994 to that in 1998?
Make the answer very short. 3.13. What is the ratio of the Amount (in current US$) in Mali in 1994 to that in 1998?
Offer a terse response. 1.51. What is the ratio of the Amount (in current US$) of Moldova in 1994 to that in 1998?
Offer a terse response. 2.35. What is the ratio of the Amount (in current US$) of Bolivia in 1994 to that in 1999?
Offer a very short reply. 1.29. What is the ratio of the Amount (in current US$) of Cameroon in 1994 to that in 1999?
Offer a terse response. 58.48. What is the ratio of the Amount (in current US$) in Mali in 1994 to that in 1999?
Your answer should be compact. 1.17. What is the ratio of the Amount (in current US$) of Moldova in 1994 to that in 1999?
Your response must be concise. 1.29. What is the ratio of the Amount (in current US$) of Bolivia in 1995 to that in 1996?
Ensure brevity in your answer.  1.72. What is the ratio of the Amount (in current US$) of Mali in 1995 to that in 1996?
Provide a short and direct response. 1.3. What is the ratio of the Amount (in current US$) in Moldova in 1995 to that in 1996?
Your response must be concise. 0.93. What is the ratio of the Amount (in current US$) of Bolivia in 1995 to that in 1997?
Give a very brief answer. 1.27. What is the ratio of the Amount (in current US$) in Mali in 1995 to that in 1997?
Give a very brief answer. 1.41. What is the ratio of the Amount (in current US$) in Moldova in 1995 to that in 1997?
Ensure brevity in your answer.  0.82. What is the ratio of the Amount (in current US$) of Bolivia in 1995 to that in 1998?
Provide a succinct answer. 4.3. What is the ratio of the Amount (in current US$) in Mali in 1995 to that in 1998?
Your answer should be very brief. 1.99. What is the ratio of the Amount (in current US$) in Moldova in 1995 to that in 1998?
Give a very brief answer. 1.1. What is the ratio of the Amount (in current US$) in Bolivia in 1995 to that in 1999?
Your answer should be compact. 1.77. What is the ratio of the Amount (in current US$) in Mali in 1995 to that in 1999?
Provide a short and direct response. 1.54. What is the ratio of the Amount (in current US$) in Moldova in 1995 to that in 1999?
Make the answer very short. 0.6. What is the ratio of the Amount (in current US$) of Bolivia in 1996 to that in 1997?
Provide a short and direct response. 0.74. What is the ratio of the Amount (in current US$) in Mali in 1996 to that in 1997?
Provide a short and direct response. 1.08. What is the ratio of the Amount (in current US$) in Moldova in 1996 to that in 1997?
Provide a short and direct response. 0.88. What is the ratio of the Amount (in current US$) in Bolivia in 1996 to that in 1998?
Provide a short and direct response. 2.5. What is the ratio of the Amount (in current US$) of Mali in 1996 to that in 1998?
Offer a terse response. 1.53. What is the ratio of the Amount (in current US$) in Moldova in 1996 to that in 1998?
Offer a very short reply. 1.18. What is the ratio of the Amount (in current US$) in Bolivia in 1996 to that in 1999?
Provide a short and direct response. 1.03. What is the ratio of the Amount (in current US$) in Mali in 1996 to that in 1999?
Offer a terse response. 1.18. What is the ratio of the Amount (in current US$) of Moldova in 1996 to that in 1999?
Offer a very short reply. 0.65. What is the ratio of the Amount (in current US$) of Bolivia in 1997 to that in 1998?
Offer a terse response. 3.38. What is the ratio of the Amount (in current US$) of Mali in 1997 to that in 1998?
Give a very brief answer. 1.41. What is the ratio of the Amount (in current US$) in Moldova in 1997 to that in 1998?
Your answer should be very brief. 1.34. What is the ratio of the Amount (in current US$) of Bolivia in 1997 to that in 1999?
Offer a very short reply. 1.4. What is the ratio of the Amount (in current US$) of Mali in 1997 to that in 1999?
Provide a succinct answer. 1.09. What is the ratio of the Amount (in current US$) of Moldova in 1997 to that in 1999?
Provide a succinct answer. 0.74. What is the ratio of the Amount (in current US$) of Bolivia in 1998 to that in 1999?
Your response must be concise. 0.41. What is the ratio of the Amount (in current US$) of Mali in 1998 to that in 1999?
Give a very brief answer. 0.77. What is the ratio of the Amount (in current US$) in Moldova in 1998 to that in 1999?
Give a very brief answer. 0.55. What is the difference between the highest and the second highest Amount (in current US$) of Bolivia?
Make the answer very short. 5.33e+07. What is the difference between the highest and the second highest Amount (in current US$) of Cameroon?
Provide a short and direct response. 9.18e+07. What is the difference between the highest and the second highest Amount (in current US$) of Mali?
Give a very brief answer. 2.87e+07. What is the difference between the highest and the second highest Amount (in current US$) in Moldova?
Provide a succinct answer. 2.22e+07. What is the difference between the highest and the lowest Amount (in current US$) of Bolivia?
Offer a very short reply. 1.92e+08. What is the difference between the highest and the lowest Amount (in current US$) in Cameroon?
Your answer should be very brief. 1.61e+08. What is the difference between the highest and the lowest Amount (in current US$) in Mali?
Keep it short and to the point. 7.63e+07. What is the difference between the highest and the lowest Amount (in current US$) in Moldova?
Offer a very short reply. 7.44e+07. 